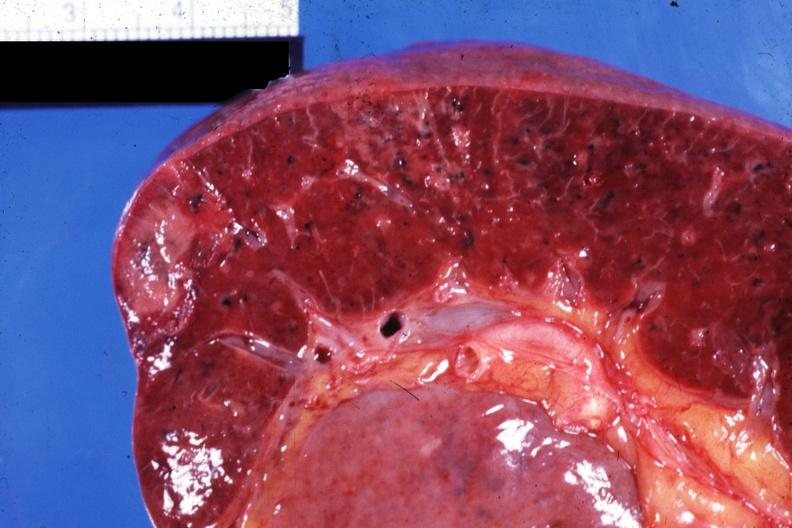what does this image show?
Answer the question using a single word or phrase. Close-up view of infarcts due to nonbacterial endocarditis 88yom with body burns 